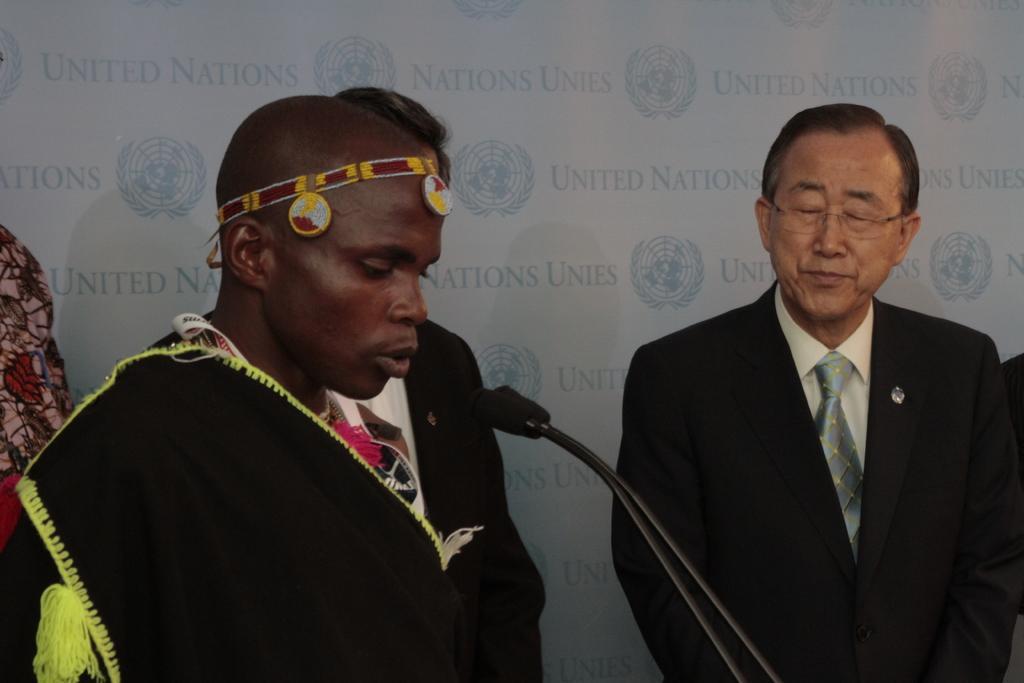Can you describe this image briefly? This picture might be taken inside a conference hall. In this image, on the left side, we can see a person wearing a black color dress is standing in front of a microphone. On the right side, we can see a man wearing black color suit is standing. In the background, we can see few people and a hoarding on which some text is written on it. 